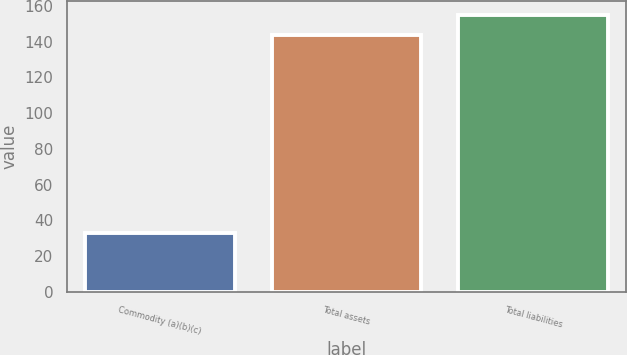Convert chart to OTSL. <chart><loc_0><loc_0><loc_500><loc_500><bar_chart><fcel>Commodity (a)(b)(c)<fcel>Total assets<fcel>Total liabilities<nl><fcel>33<fcel>144<fcel>155.2<nl></chart> 